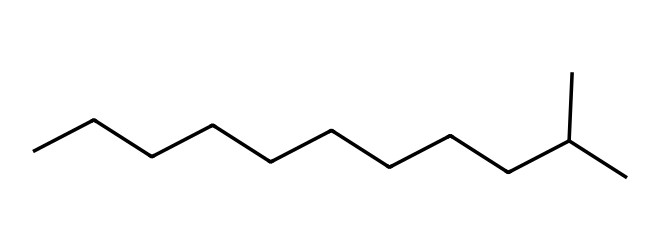What is the total number of carbon atoms in this hydrocarbon? The SMILES representation indicates a hydrocarbon chain with "C" symbols. Counting them, there are 12 carbon atoms in this structure, combined with a branched chain.
Answer: twelve How many hydrogen atoms are present in this chemical? For alkanes, the formula is CnH(2n+2). With 12 carbon atoms (n=12), the number of hydrogen atoms would be 2(12)+2, resulting in 26 hydrogen atoms.
Answer: twenty-six Is this hydrocarbon a straight chain or branched? The presence of the branched structure, indicated by "(C)" in the SMILES notation, signifies that it is a branched hydrocarbon rather than a straight-chain alkane.
Answer: branched What type of hydrocarbon does this compound represent? This compound contains only carbon and hydrogen atoms, fitting the definition of an alkane, as it is fully saturated and has no double or triple bonds.
Answer: alkane What is the molecular formula of this hydrocarbon? Based on the information gathered earlier, the molecular formula is derived from the number of carbon atom (C) and hydrogen atom (H). It can be represented as C12H26.
Answer: C12H26 What physical properties are expected from this hydrocarbon? Given that this is an alkane with a higher molecular weight due to its carbon and hydrogen content, it is expected to have properties like being nonpolar and having a relatively high boiling point compared to smaller alkanes, suitable for jet fuel applications.
Answer: high boiling point What common use does this hydrocarbon have? This hydrocarbon, being a branched alkane, is typically used as jet fuel due to its energy density and suitable combustion properties.
Answer: jet fuel 